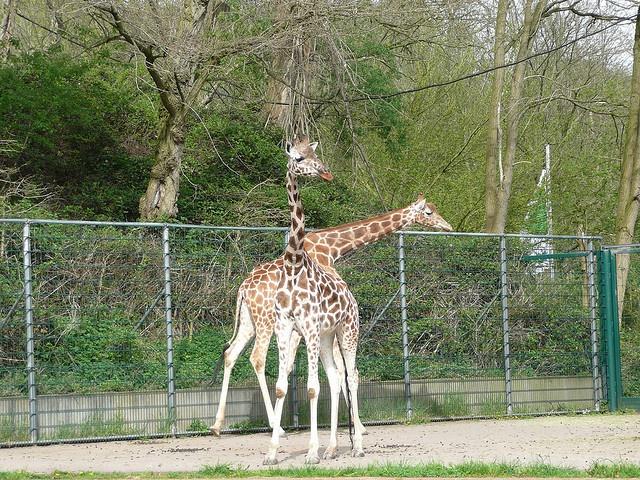Describe the objects in this image and their specific colors. I can see giraffe in tan, white, gray, and darkgray tones and giraffe in tan, ivory, and gray tones in this image. 